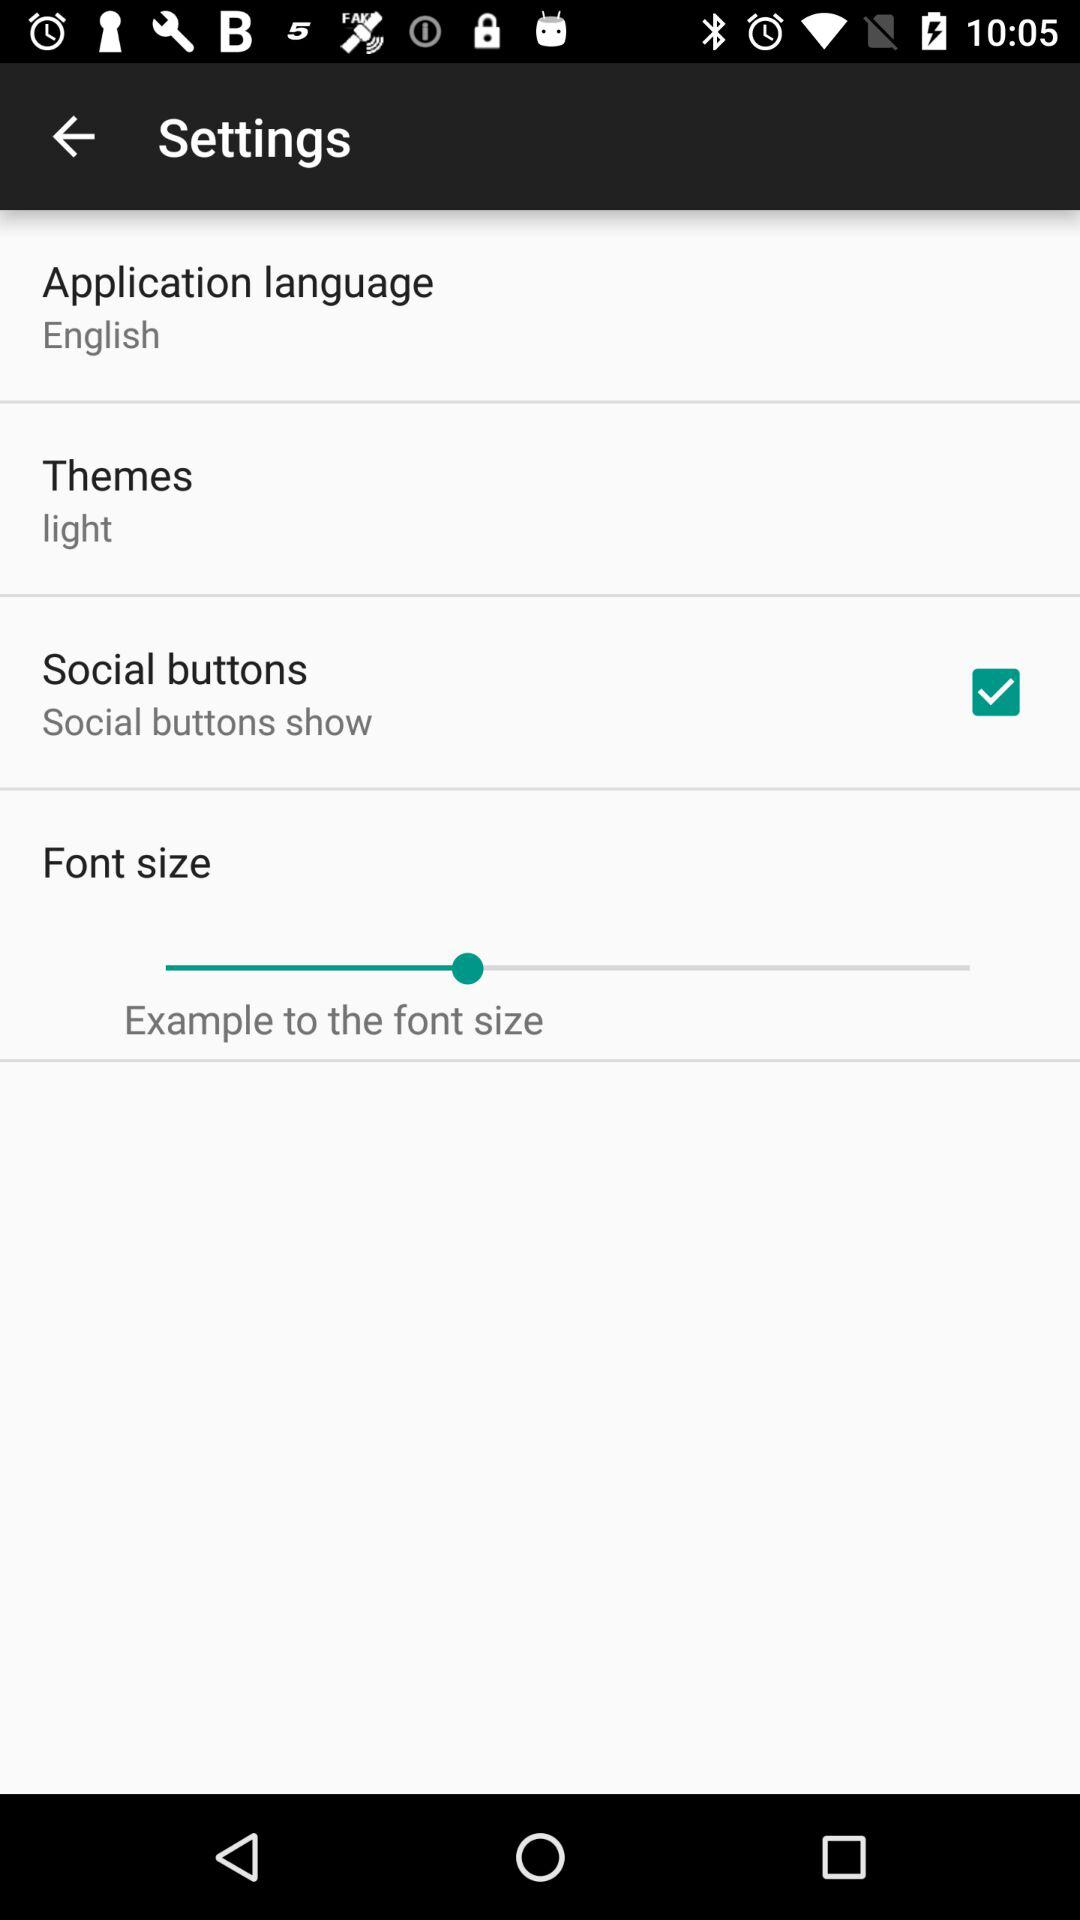What is the selected theme? The selected theme is "light". 